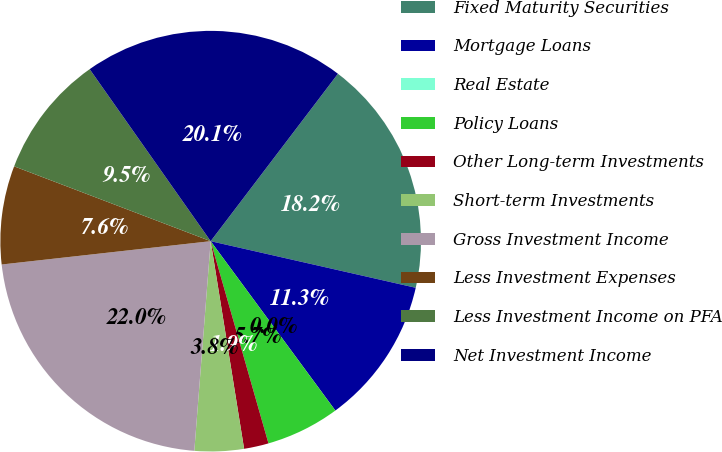Convert chart. <chart><loc_0><loc_0><loc_500><loc_500><pie_chart><fcel>Fixed Maturity Securities<fcel>Mortgage Loans<fcel>Real Estate<fcel>Policy Loans<fcel>Other Long-term Investments<fcel>Short-term Investments<fcel>Gross Investment Income<fcel>Less Investment Expenses<fcel>Less Investment Income on PFA<fcel>Net Investment Income<nl><fcel>18.21%<fcel>11.34%<fcel>0.0%<fcel>5.67%<fcel>1.89%<fcel>3.78%<fcel>21.99%<fcel>7.56%<fcel>9.45%<fcel>20.1%<nl></chart> 